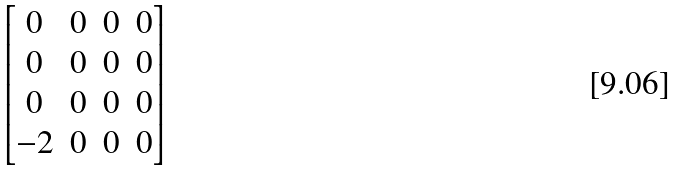Convert formula to latex. <formula><loc_0><loc_0><loc_500><loc_500>\begin{bmatrix} 0 & 0 & 0 & 0 \\ 0 & 0 & 0 & 0 \\ 0 & 0 & 0 & 0 \\ - 2 & 0 & 0 & 0 \end{bmatrix}</formula> 